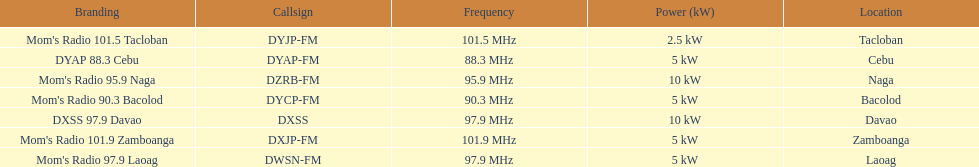How many stations have at least 5 kw or more listed in the power column? 6. 